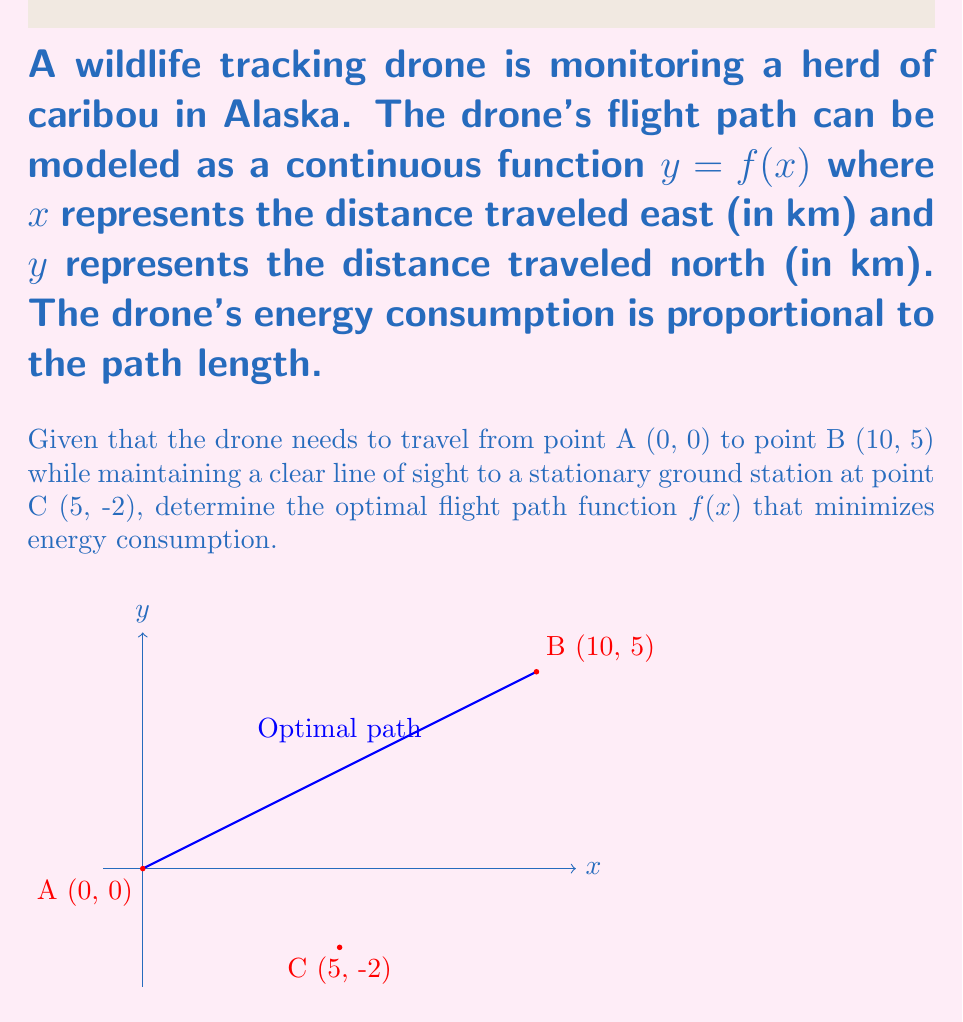What is the answer to this math problem? To solve this problem, we'll use the calculus of variations to find the optimal path that minimizes energy consumption while satisfying the line-of-sight constraint.

Step 1: Set up the functional to be minimized
The length of the path is given by the arc length formula:
$$L = \int_0^{10} \sqrt{1 + [f'(x)]^2} dx$$

Step 2: Consider the line-of-sight constraint
For any point $(x, f(x))$ on the path, it must form a straight line with C (5, -2) that doesn't intersect the ground. This can be expressed as:
$$f(x) \geq -2 + \frac{7}{5}(x-5)$$

Step 3: Apply the Euler-Lagrange equation
The Euler-Lagrange equation for this problem is:
$$\frac{d}{dx}\left(\frac{\partial F}{\partial y'}\right) - \frac{\partial F}{\partial y} = 0$$
where $F = \sqrt{1 + [f'(x)]^2}$

Step 4: Solve the Euler-Lagrange equation
Applying the equation yields:
$$\frac{d}{dx}\left(\frac{f'(x)}{\sqrt{1 + [f'(x)]^2}}\right) = 0$$

Integrating both sides:
$$\frac{f'(x)}{\sqrt{1 + [f'(x)]^2}} = C_1$$

Step 5: Solve for $f'(x)$
$$f'(x) = \frac{C_1}{\sqrt{1 - C_1^2}}$$

Step 6: Integrate to find $f(x)$
$$f(x) = \frac{C_1}{\sqrt{1 - C_1^2}}x + C_2$$

Step 7: Apply boundary conditions
Using $f(0) = 0$ and $f(10) = 5$, we can solve for $C_1$ and $C_2$:
$$C_2 = 0$$
$$C_1 = \frac{1}{2}$$

Step 8: Final optimal path function
$$f(x) = \frac{1}{2}x$$

This linear function satisfies the line-of-sight constraint and minimizes the path length, thus optimizing energy consumption.
Answer: $f(x) = \frac{1}{2}x$ 